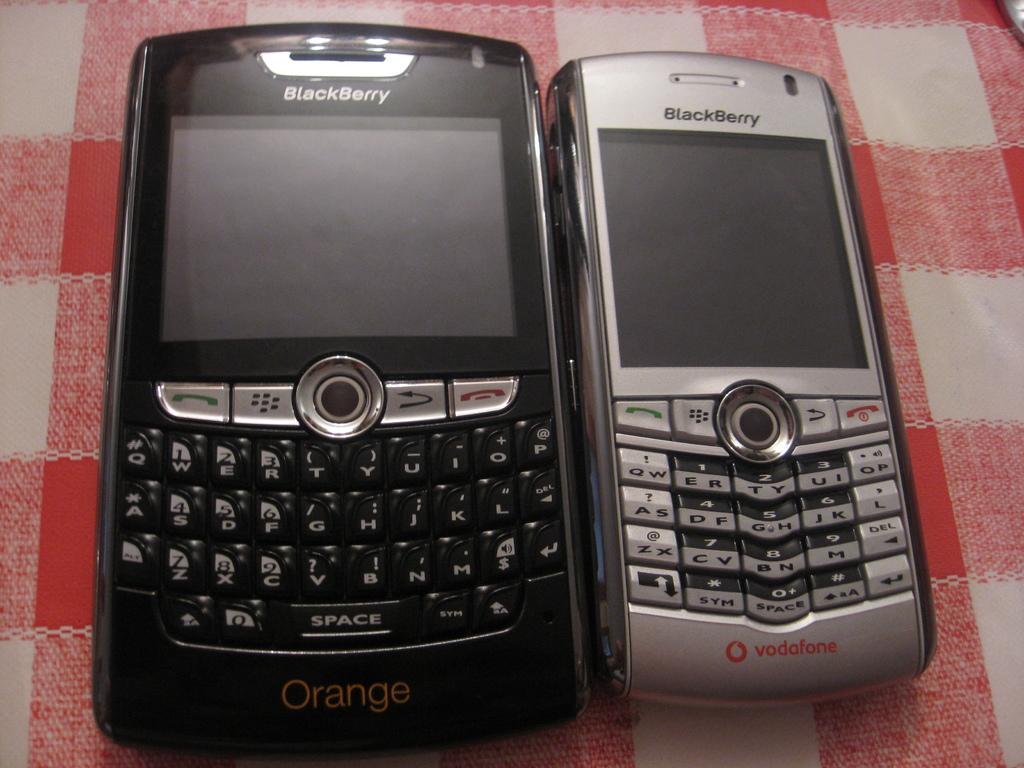Provide a one-sentence caption for the provided image. Two blackberry phones are on a red and white checkered tablecloth, the bigger one says Orange and the smaller one vodafone on the bottom. 